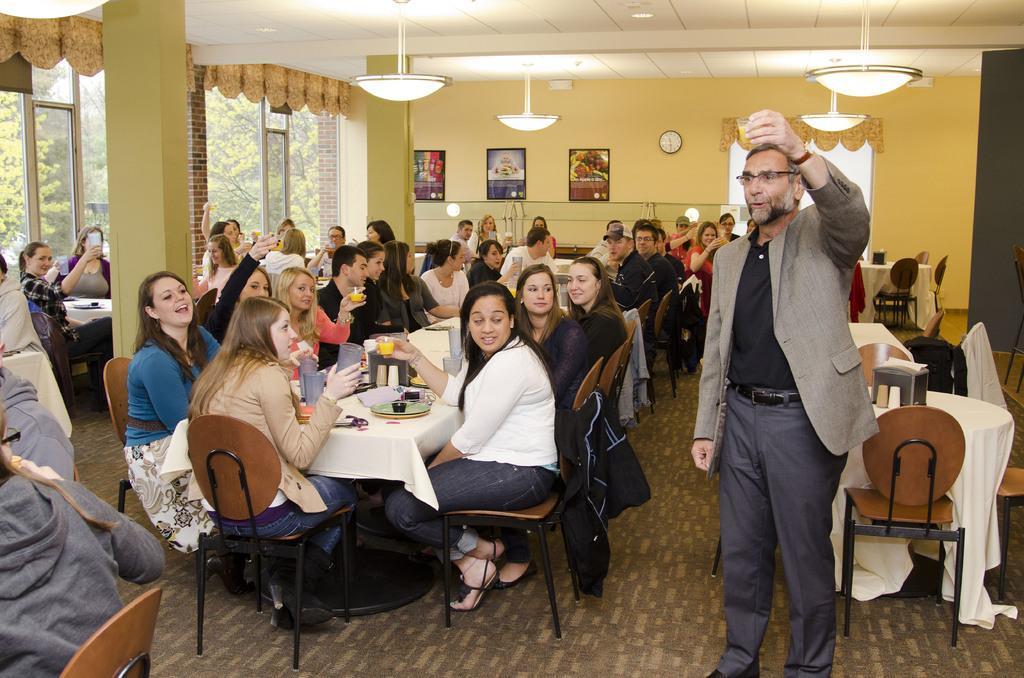Can you describe this image briefly? The person wearing a coat is standing and holding a drink in his left hand and there are group of people beside and the background wall is light yellow in color. 